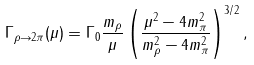Convert formula to latex. <formula><loc_0><loc_0><loc_500><loc_500>\Gamma _ { \rho { \to } 2 \pi } ( \mu ) = \Gamma _ { 0 } \frac { m _ { \rho } } { \mu } \left ( \frac { \mu ^ { 2 } - 4 m _ { \pi } ^ { 2 } } { m _ { \rho } ^ { 2 } - 4 m _ { \pi } ^ { 2 } } \right ) ^ { 3 / 2 } ,</formula> 